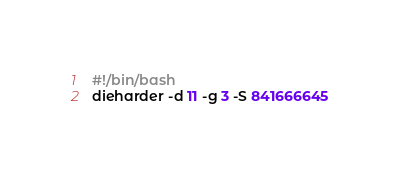Convert code to text. <code><loc_0><loc_0><loc_500><loc_500><_Bash_>#!/bin/bash
dieharder -d 11 -g 3 -S 841666645
</code> 